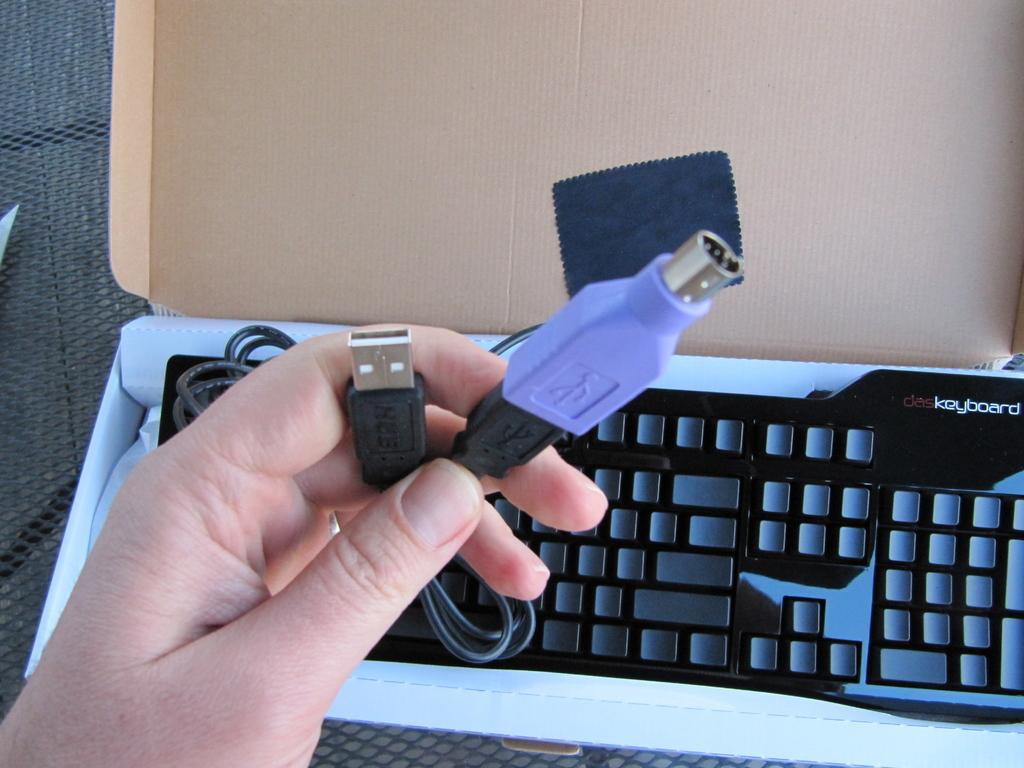Provide a one-sentence caption for the provided image. The USB cords need to plug into the DAS Keyboard. 